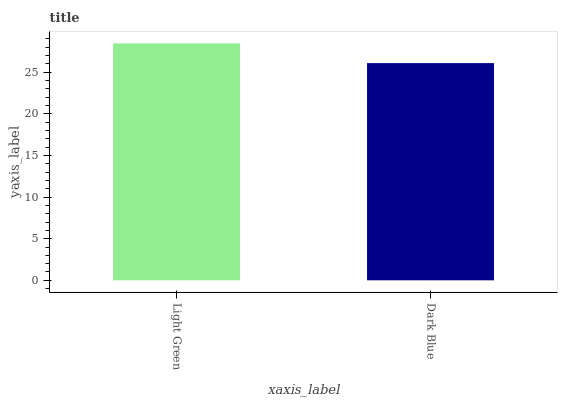Is Dark Blue the minimum?
Answer yes or no. Yes. Is Light Green the maximum?
Answer yes or no. Yes. Is Dark Blue the maximum?
Answer yes or no. No. Is Light Green greater than Dark Blue?
Answer yes or no. Yes. Is Dark Blue less than Light Green?
Answer yes or no. Yes. Is Dark Blue greater than Light Green?
Answer yes or no. No. Is Light Green less than Dark Blue?
Answer yes or no. No. Is Light Green the high median?
Answer yes or no. Yes. Is Dark Blue the low median?
Answer yes or no. Yes. Is Dark Blue the high median?
Answer yes or no. No. Is Light Green the low median?
Answer yes or no. No. 